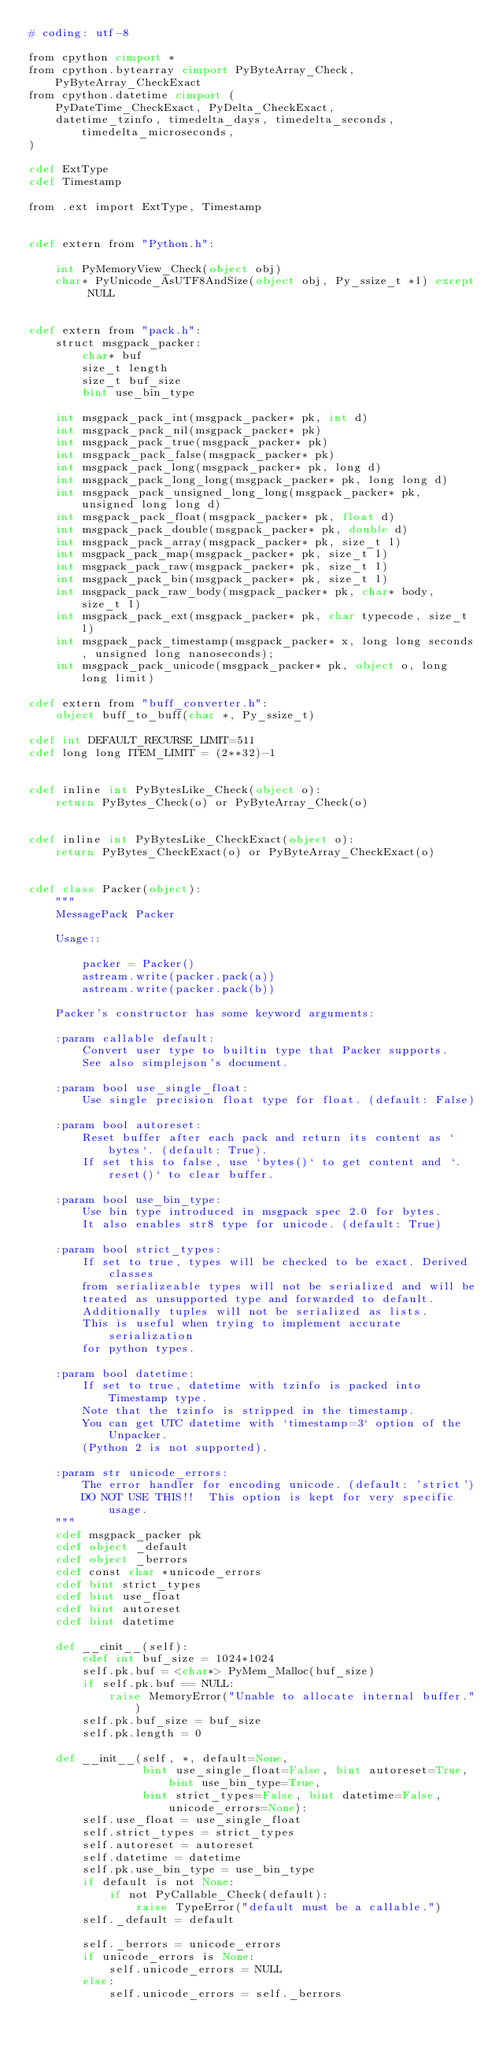Convert code to text. <code><loc_0><loc_0><loc_500><loc_500><_Cython_># coding: utf-8

from cpython cimport *
from cpython.bytearray cimport PyByteArray_Check, PyByteArray_CheckExact
from cpython.datetime cimport (
    PyDateTime_CheckExact, PyDelta_CheckExact,
    datetime_tzinfo, timedelta_days, timedelta_seconds, timedelta_microseconds,
)

cdef ExtType
cdef Timestamp

from .ext import ExtType, Timestamp


cdef extern from "Python.h":

    int PyMemoryView_Check(object obj)
    char* PyUnicode_AsUTF8AndSize(object obj, Py_ssize_t *l) except NULL


cdef extern from "pack.h":
    struct msgpack_packer:
        char* buf
        size_t length
        size_t buf_size
        bint use_bin_type

    int msgpack_pack_int(msgpack_packer* pk, int d)
    int msgpack_pack_nil(msgpack_packer* pk)
    int msgpack_pack_true(msgpack_packer* pk)
    int msgpack_pack_false(msgpack_packer* pk)
    int msgpack_pack_long(msgpack_packer* pk, long d)
    int msgpack_pack_long_long(msgpack_packer* pk, long long d)
    int msgpack_pack_unsigned_long_long(msgpack_packer* pk, unsigned long long d)
    int msgpack_pack_float(msgpack_packer* pk, float d)
    int msgpack_pack_double(msgpack_packer* pk, double d)
    int msgpack_pack_array(msgpack_packer* pk, size_t l)
    int msgpack_pack_map(msgpack_packer* pk, size_t l)
    int msgpack_pack_raw(msgpack_packer* pk, size_t l)
    int msgpack_pack_bin(msgpack_packer* pk, size_t l)
    int msgpack_pack_raw_body(msgpack_packer* pk, char* body, size_t l)
    int msgpack_pack_ext(msgpack_packer* pk, char typecode, size_t l)
    int msgpack_pack_timestamp(msgpack_packer* x, long long seconds, unsigned long nanoseconds);
    int msgpack_pack_unicode(msgpack_packer* pk, object o, long long limit)

cdef extern from "buff_converter.h":
    object buff_to_buff(char *, Py_ssize_t)

cdef int DEFAULT_RECURSE_LIMIT=511
cdef long long ITEM_LIMIT = (2**32)-1


cdef inline int PyBytesLike_Check(object o):
    return PyBytes_Check(o) or PyByteArray_Check(o)


cdef inline int PyBytesLike_CheckExact(object o):
    return PyBytes_CheckExact(o) or PyByteArray_CheckExact(o)


cdef class Packer(object):
    """
    MessagePack Packer

    Usage::

        packer = Packer()
        astream.write(packer.pack(a))
        astream.write(packer.pack(b))

    Packer's constructor has some keyword arguments:

    :param callable default:
        Convert user type to builtin type that Packer supports.
        See also simplejson's document.

    :param bool use_single_float:
        Use single precision float type for float. (default: False)

    :param bool autoreset:
        Reset buffer after each pack and return its content as `bytes`. (default: True).
        If set this to false, use `bytes()` to get content and `.reset()` to clear buffer.

    :param bool use_bin_type:
        Use bin type introduced in msgpack spec 2.0 for bytes.
        It also enables str8 type for unicode. (default: True)

    :param bool strict_types:
        If set to true, types will be checked to be exact. Derived classes
        from serializeable types will not be serialized and will be
        treated as unsupported type and forwarded to default.
        Additionally tuples will not be serialized as lists.
        This is useful when trying to implement accurate serialization
        for python types.

    :param bool datetime:
        If set to true, datetime with tzinfo is packed into Timestamp type.
        Note that the tzinfo is stripped in the timestamp.
        You can get UTC datetime with `timestamp=3` option of the Unpacker.
        (Python 2 is not supported).

    :param str unicode_errors:
        The error handler for encoding unicode. (default: 'strict')
        DO NOT USE THIS!!  This option is kept for very specific usage.
    """
    cdef msgpack_packer pk
    cdef object _default
    cdef object _berrors
    cdef const char *unicode_errors
    cdef bint strict_types
    cdef bint use_float
    cdef bint autoreset
    cdef bint datetime

    def __cinit__(self):
        cdef int buf_size = 1024*1024
        self.pk.buf = <char*> PyMem_Malloc(buf_size)
        if self.pk.buf == NULL:
            raise MemoryError("Unable to allocate internal buffer.")
        self.pk.buf_size = buf_size
        self.pk.length = 0

    def __init__(self, *, default=None,
                 bint use_single_float=False, bint autoreset=True, bint use_bin_type=True,
                 bint strict_types=False, bint datetime=False, unicode_errors=None):
        self.use_float = use_single_float
        self.strict_types = strict_types
        self.autoreset = autoreset
        self.datetime = datetime
        self.pk.use_bin_type = use_bin_type
        if default is not None:
            if not PyCallable_Check(default):
                raise TypeError("default must be a callable.")
        self._default = default

        self._berrors = unicode_errors
        if unicode_errors is None:
            self.unicode_errors = NULL
        else:
            self.unicode_errors = self._berrors
</code> 